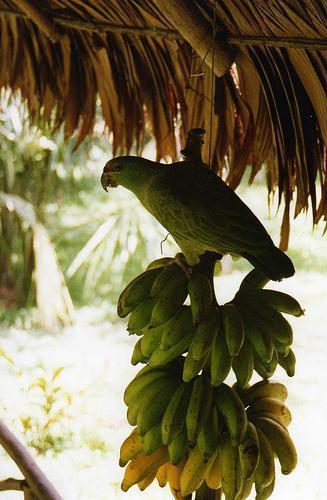How many birds are in this photo?
Give a very brief answer. 1. How many beaks does the bird have?
Give a very brief answer. 1. 